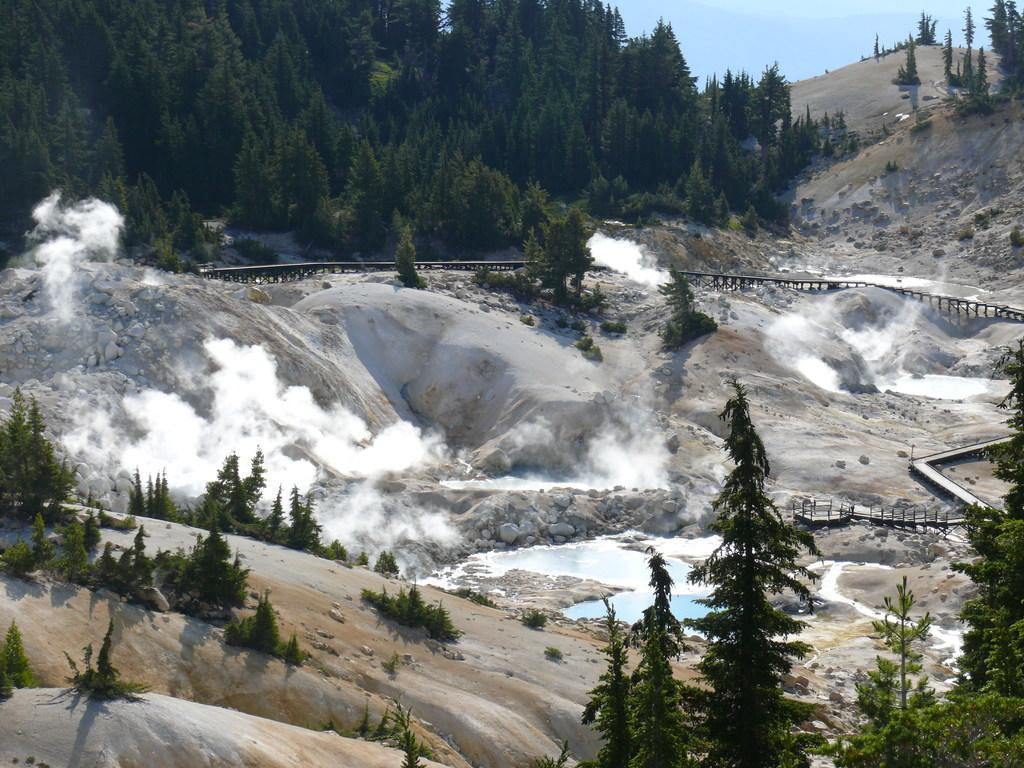How would you summarize this image in a sentence or two? In the picture I can see trees, stones, water, white color smoke, hills and the blue color sky in the background. 